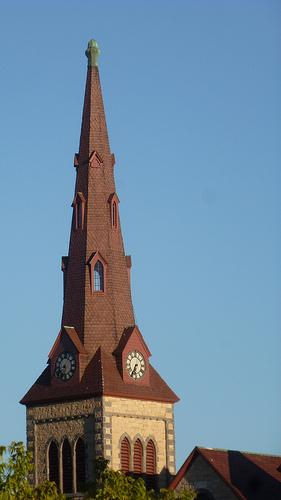Analyze the sentiment of the image. The image elicits a peaceful, serene, and nostalgic sentiment due to the architectural features of the clock tower, green leaves, and clear blue sky. List some prominent features of the image that would aid in segmenting it. Features useful for segmentation include the clock tower, brown roof and steeple, blue sky, green leaves, red vents, brick walls, and windows. What can you infer about the time of day when the image was captured? Based on the clear blue sky and the time shown on the clocks (5:35), it appears to be a day time picture, likely in the evening. Explain the context of the image in terms of its setting. The image's setting is likely an old or historically significant town or city, as the clock tower and surrounding architecture convey a sense of history and tradition. Identify the main colors present in the image. The main colors in the image are blue, brown, green, red, black, white, and tan. Provide a brief description of the scene in the image. The image features a tan and brown clock tower with two black and white clocks with roman numerals, a brown roof and steeple, red vents, and a clear blue sky with green leaves in the foreground. Determine some relationships between the objects in the image, which can be used for a complex reasoning task. Relationships include the clocks being part of the clock tower, the red vents being part of the side of the building, the steeple being related to the roof, and the position of green leaves indicating the presence of a garden or trees nearby. Describe some architectural details visible in the image. Architectural details in the image include a brown steeple, red vents on the side of the building, a copper tip on the top of the building, green leaves surrounding the base, and brick walls with windows. If there were an anomaly in the image, what would be considered an unusual feature? If present, an unusual feature could be a rooftop clock showing a different time than the others, thus being an anomaly in the context of the other clocks. What is the time shown on the black and white clocks in the clock tower? The time shown on the black and white clocks is 5:35. 